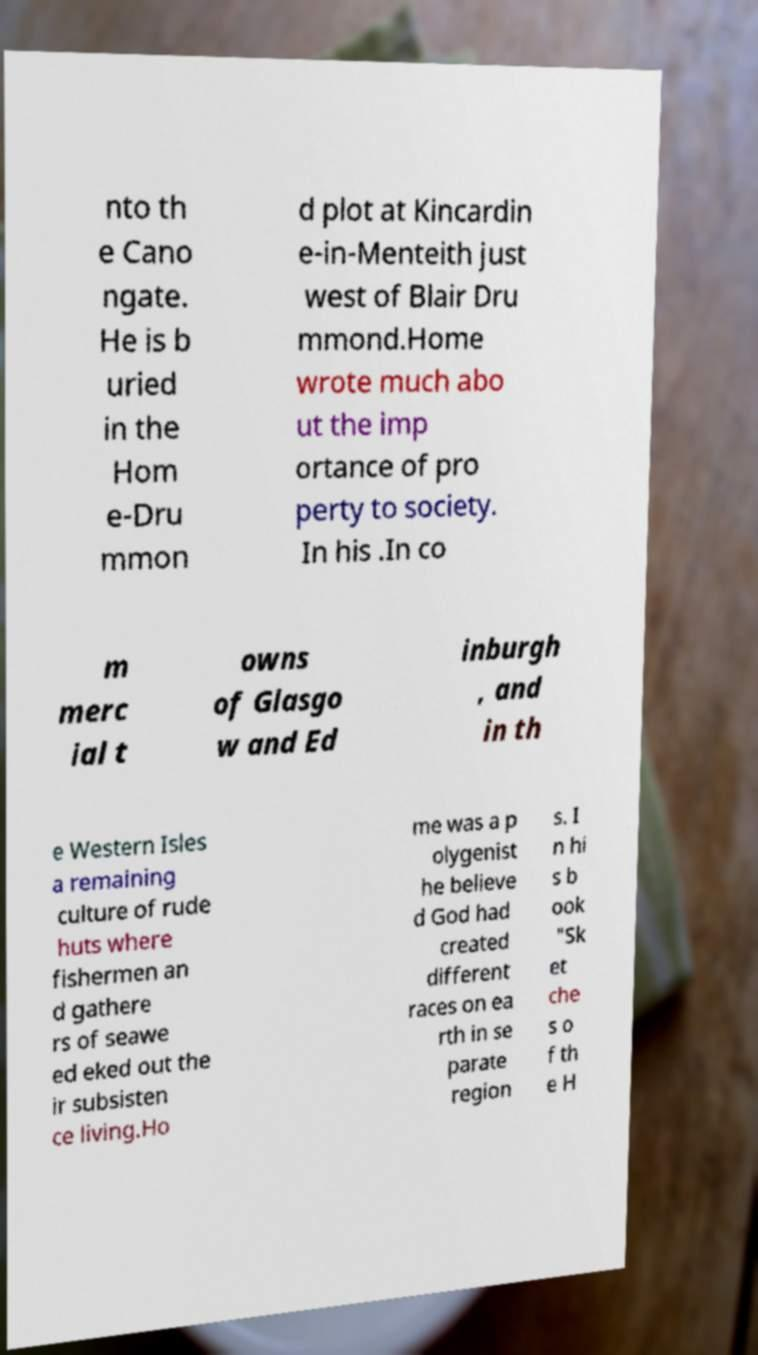Please identify and transcribe the text found in this image. nto th e Cano ngate. He is b uried in the Hom e-Dru mmon d plot at Kincardin e-in-Menteith just west of Blair Dru mmond.Home wrote much abo ut the imp ortance of pro perty to society. In his .In co m merc ial t owns of Glasgo w and Ed inburgh , and in th e Western Isles a remaining culture of rude huts where fishermen an d gathere rs of seawe ed eked out the ir subsisten ce living.Ho me was a p olygenist he believe d God had created different races on ea rth in se parate region s. I n hi s b ook "Sk et che s o f th e H 